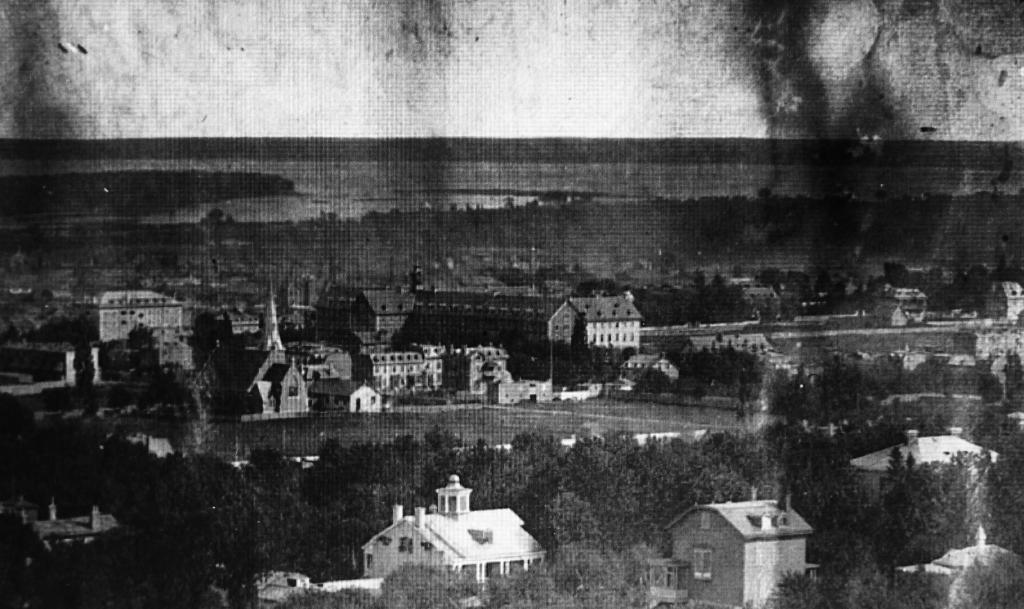What is the color scheme of the image? The image is black and white. What is the main subject of the image? The image depicts a city. What structures can be seen in the image? There are buildings in the image. What type of natural elements are present in the image? There are trees and water visible in the image. What part of the natural environment is visible in the image? The sky is visible in the image. What type of list is the queen holding in the image? There is no queen or list present in the image. What type of rail can be seen connecting the buildings in the image? There is no rail connecting the buildings in the image. 